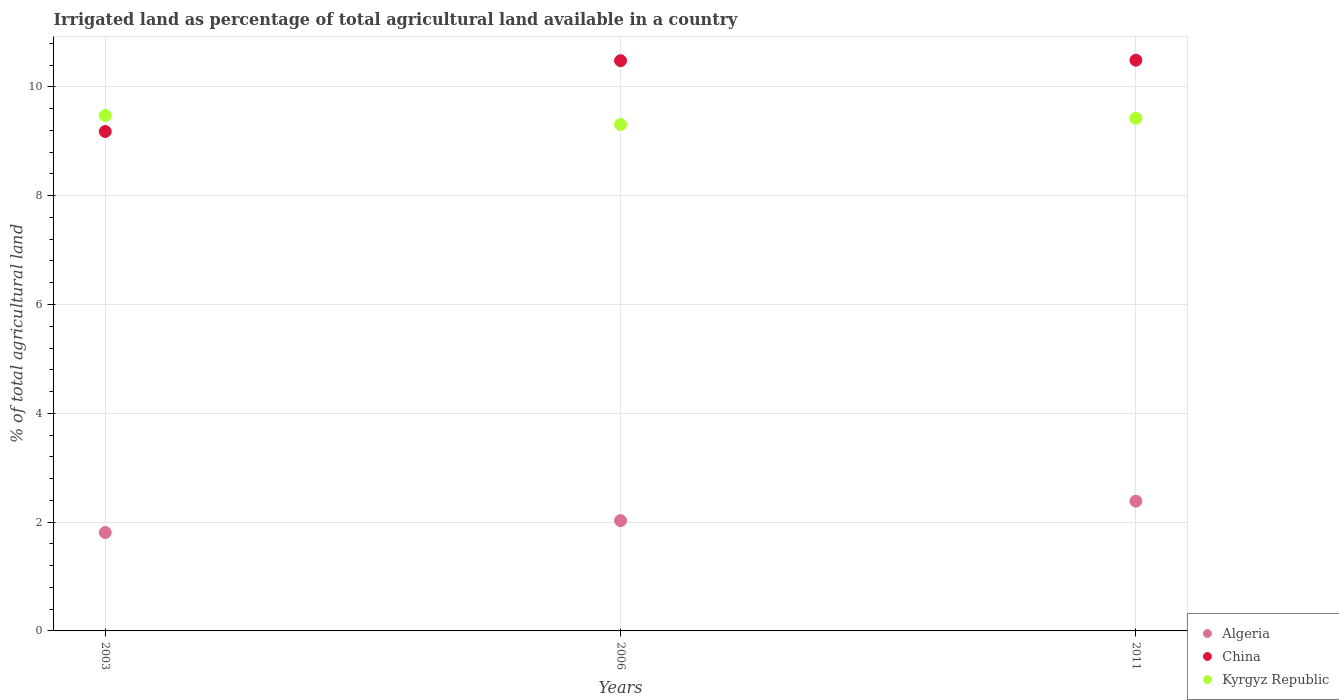How many different coloured dotlines are there?
Keep it short and to the point. 3. Is the number of dotlines equal to the number of legend labels?
Provide a short and direct response. Yes. What is the percentage of irrigated land in Kyrgyz Republic in 2011?
Your response must be concise. 9.42. Across all years, what is the maximum percentage of irrigated land in Kyrgyz Republic?
Your answer should be very brief. 9.47. Across all years, what is the minimum percentage of irrigated land in Algeria?
Provide a succinct answer. 1.81. In which year was the percentage of irrigated land in Kyrgyz Republic maximum?
Offer a terse response. 2003. In which year was the percentage of irrigated land in China minimum?
Offer a terse response. 2003. What is the total percentage of irrigated land in China in the graph?
Your answer should be very brief. 30.15. What is the difference between the percentage of irrigated land in Kyrgyz Republic in 2006 and that in 2011?
Your answer should be very brief. -0.11. What is the difference between the percentage of irrigated land in China in 2006 and the percentage of irrigated land in Algeria in 2011?
Your answer should be compact. 8.1. What is the average percentage of irrigated land in Kyrgyz Republic per year?
Offer a very short reply. 9.4. In the year 2003, what is the difference between the percentage of irrigated land in Algeria and percentage of irrigated land in China?
Give a very brief answer. -7.37. In how many years, is the percentage of irrigated land in Kyrgyz Republic greater than 1.6 %?
Your answer should be very brief. 3. What is the ratio of the percentage of irrigated land in China in 2006 to that in 2011?
Make the answer very short. 1. What is the difference between the highest and the second highest percentage of irrigated land in China?
Provide a short and direct response. 0.01. What is the difference between the highest and the lowest percentage of irrigated land in Algeria?
Your answer should be compact. 0.58. In how many years, is the percentage of irrigated land in Kyrgyz Republic greater than the average percentage of irrigated land in Kyrgyz Republic taken over all years?
Your answer should be very brief. 2. Is the sum of the percentage of irrigated land in China in 2003 and 2006 greater than the maximum percentage of irrigated land in Kyrgyz Republic across all years?
Provide a short and direct response. Yes. Is it the case that in every year, the sum of the percentage of irrigated land in Kyrgyz Republic and percentage of irrigated land in Algeria  is greater than the percentage of irrigated land in China?
Your answer should be compact. Yes. Does the percentage of irrigated land in China monotonically increase over the years?
Provide a short and direct response. Yes. How many dotlines are there?
Offer a very short reply. 3. What is the difference between two consecutive major ticks on the Y-axis?
Your response must be concise. 2. Are the values on the major ticks of Y-axis written in scientific E-notation?
Make the answer very short. No. Where does the legend appear in the graph?
Offer a very short reply. Bottom right. What is the title of the graph?
Ensure brevity in your answer.  Irrigated land as percentage of total agricultural land available in a country. Does "Bahamas" appear as one of the legend labels in the graph?
Your response must be concise. No. What is the label or title of the X-axis?
Keep it short and to the point. Years. What is the label or title of the Y-axis?
Your answer should be compact. % of total agricultural land. What is the % of total agricultural land of Algeria in 2003?
Make the answer very short. 1.81. What is the % of total agricultural land of China in 2003?
Offer a very short reply. 9.18. What is the % of total agricultural land of Kyrgyz Republic in 2003?
Provide a succinct answer. 9.47. What is the % of total agricultural land in Algeria in 2006?
Your response must be concise. 2.03. What is the % of total agricultural land of China in 2006?
Ensure brevity in your answer.  10.48. What is the % of total agricultural land of Kyrgyz Republic in 2006?
Your answer should be compact. 9.31. What is the % of total agricultural land in Algeria in 2011?
Keep it short and to the point. 2.38. What is the % of total agricultural land of China in 2011?
Offer a very short reply. 10.49. What is the % of total agricultural land of Kyrgyz Republic in 2011?
Give a very brief answer. 9.42. Across all years, what is the maximum % of total agricultural land in Algeria?
Give a very brief answer. 2.38. Across all years, what is the maximum % of total agricultural land in China?
Offer a terse response. 10.49. Across all years, what is the maximum % of total agricultural land of Kyrgyz Republic?
Ensure brevity in your answer.  9.47. Across all years, what is the minimum % of total agricultural land of Algeria?
Offer a very short reply. 1.81. Across all years, what is the minimum % of total agricultural land of China?
Your answer should be compact. 9.18. Across all years, what is the minimum % of total agricultural land in Kyrgyz Republic?
Your answer should be very brief. 9.31. What is the total % of total agricultural land of Algeria in the graph?
Keep it short and to the point. 6.22. What is the total % of total agricultural land in China in the graph?
Offer a terse response. 30.15. What is the total % of total agricultural land of Kyrgyz Republic in the graph?
Give a very brief answer. 28.21. What is the difference between the % of total agricultural land in Algeria in 2003 and that in 2006?
Your answer should be very brief. -0.22. What is the difference between the % of total agricultural land of China in 2003 and that in 2006?
Your response must be concise. -1.3. What is the difference between the % of total agricultural land in Kyrgyz Republic in 2003 and that in 2006?
Ensure brevity in your answer.  0.17. What is the difference between the % of total agricultural land of Algeria in 2003 and that in 2011?
Your answer should be very brief. -0.58. What is the difference between the % of total agricultural land in China in 2003 and that in 2011?
Provide a short and direct response. -1.31. What is the difference between the % of total agricultural land in Kyrgyz Republic in 2003 and that in 2011?
Provide a short and direct response. 0.05. What is the difference between the % of total agricultural land in Algeria in 2006 and that in 2011?
Ensure brevity in your answer.  -0.36. What is the difference between the % of total agricultural land in China in 2006 and that in 2011?
Your answer should be very brief. -0.01. What is the difference between the % of total agricultural land of Kyrgyz Republic in 2006 and that in 2011?
Make the answer very short. -0.11. What is the difference between the % of total agricultural land of Algeria in 2003 and the % of total agricultural land of China in 2006?
Provide a succinct answer. -8.67. What is the difference between the % of total agricultural land of Algeria in 2003 and the % of total agricultural land of Kyrgyz Republic in 2006?
Provide a succinct answer. -7.5. What is the difference between the % of total agricultural land of China in 2003 and the % of total agricultural land of Kyrgyz Republic in 2006?
Ensure brevity in your answer.  -0.13. What is the difference between the % of total agricultural land in Algeria in 2003 and the % of total agricultural land in China in 2011?
Keep it short and to the point. -8.68. What is the difference between the % of total agricultural land of Algeria in 2003 and the % of total agricultural land of Kyrgyz Republic in 2011?
Ensure brevity in your answer.  -7.61. What is the difference between the % of total agricultural land of China in 2003 and the % of total agricultural land of Kyrgyz Republic in 2011?
Give a very brief answer. -0.24. What is the difference between the % of total agricultural land of Algeria in 2006 and the % of total agricultural land of China in 2011?
Your answer should be compact. -8.46. What is the difference between the % of total agricultural land of Algeria in 2006 and the % of total agricultural land of Kyrgyz Republic in 2011?
Keep it short and to the point. -7.39. What is the difference between the % of total agricultural land of China in 2006 and the % of total agricultural land of Kyrgyz Republic in 2011?
Your answer should be very brief. 1.06. What is the average % of total agricultural land of Algeria per year?
Give a very brief answer. 2.07. What is the average % of total agricultural land of China per year?
Provide a succinct answer. 10.05. What is the average % of total agricultural land of Kyrgyz Republic per year?
Make the answer very short. 9.4. In the year 2003, what is the difference between the % of total agricultural land of Algeria and % of total agricultural land of China?
Provide a succinct answer. -7.37. In the year 2003, what is the difference between the % of total agricultural land in Algeria and % of total agricultural land in Kyrgyz Republic?
Keep it short and to the point. -7.66. In the year 2003, what is the difference between the % of total agricultural land of China and % of total agricultural land of Kyrgyz Republic?
Keep it short and to the point. -0.29. In the year 2006, what is the difference between the % of total agricultural land in Algeria and % of total agricultural land in China?
Your answer should be very brief. -8.45. In the year 2006, what is the difference between the % of total agricultural land in Algeria and % of total agricultural land in Kyrgyz Republic?
Offer a very short reply. -7.28. In the year 2006, what is the difference between the % of total agricultural land in China and % of total agricultural land in Kyrgyz Republic?
Offer a terse response. 1.17. In the year 2011, what is the difference between the % of total agricultural land of Algeria and % of total agricultural land of China?
Your response must be concise. -8.11. In the year 2011, what is the difference between the % of total agricultural land of Algeria and % of total agricultural land of Kyrgyz Republic?
Provide a short and direct response. -7.04. In the year 2011, what is the difference between the % of total agricultural land in China and % of total agricultural land in Kyrgyz Republic?
Give a very brief answer. 1.07. What is the ratio of the % of total agricultural land of Algeria in 2003 to that in 2006?
Offer a very short reply. 0.89. What is the ratio of the % of total agricultural land of China in 2003 to that in 2006?
Your answer should be very brief. 0.88. What is the ratio of the % of total agricultural land of Kyrgyz Republic in 2003 to that in 2006?
Make the answer very short. 1.02. What is the ratio of the % of total agricultural land in Algeria in 2003 to that in 2011?
Your answer should be very brief. 0.76. What is the ratio of the % of total agricultural land in China in 2003 to that in 2011?
Ensure brevity in your answer.  0.88. What is the ratio of the % of total agricultural land of Kyrgyz Republic in 2003 to that in 2011?
Provide a succinct answer. 1.01. What is the ratio of the % of total agricultural land in Algeria in 2006 to that in 2011?
Your answer should be compact. 0.85. What is the ratio of the % of total agricultural land of China in 2006 to that in 2011?
Keep it short and to the point. 1. What is the ratio of the % of total agricultural land in Kyrgyz Republic in 2006 to that in 2011?
Your answer should be compact. 0.99. What is the difference between the highest and the second highest % of total agricultural land of Algeria?
Provide a succinct answer. 0.36. What is the difference between the highest and the second highest % of total agricultural land of China?
Your response must be concise. 0.01. What is the difference between the highest and the second highest % of total agricultural land in Kyrgyz Republic?
Offer a terse response. 0.05. What is the difference between the highest and the lowest % of total agricultural land in Algeria?
Your answer should be compact. 0.58. What is the difference between the highest and the lowest % of total agricultural land of China?
Provide a succinct answer. 1.31. What is the difference between the highest and the lowest % of total agricultural land in Kyrgyz Republic?
Provide a short and direct response. 0.17. 